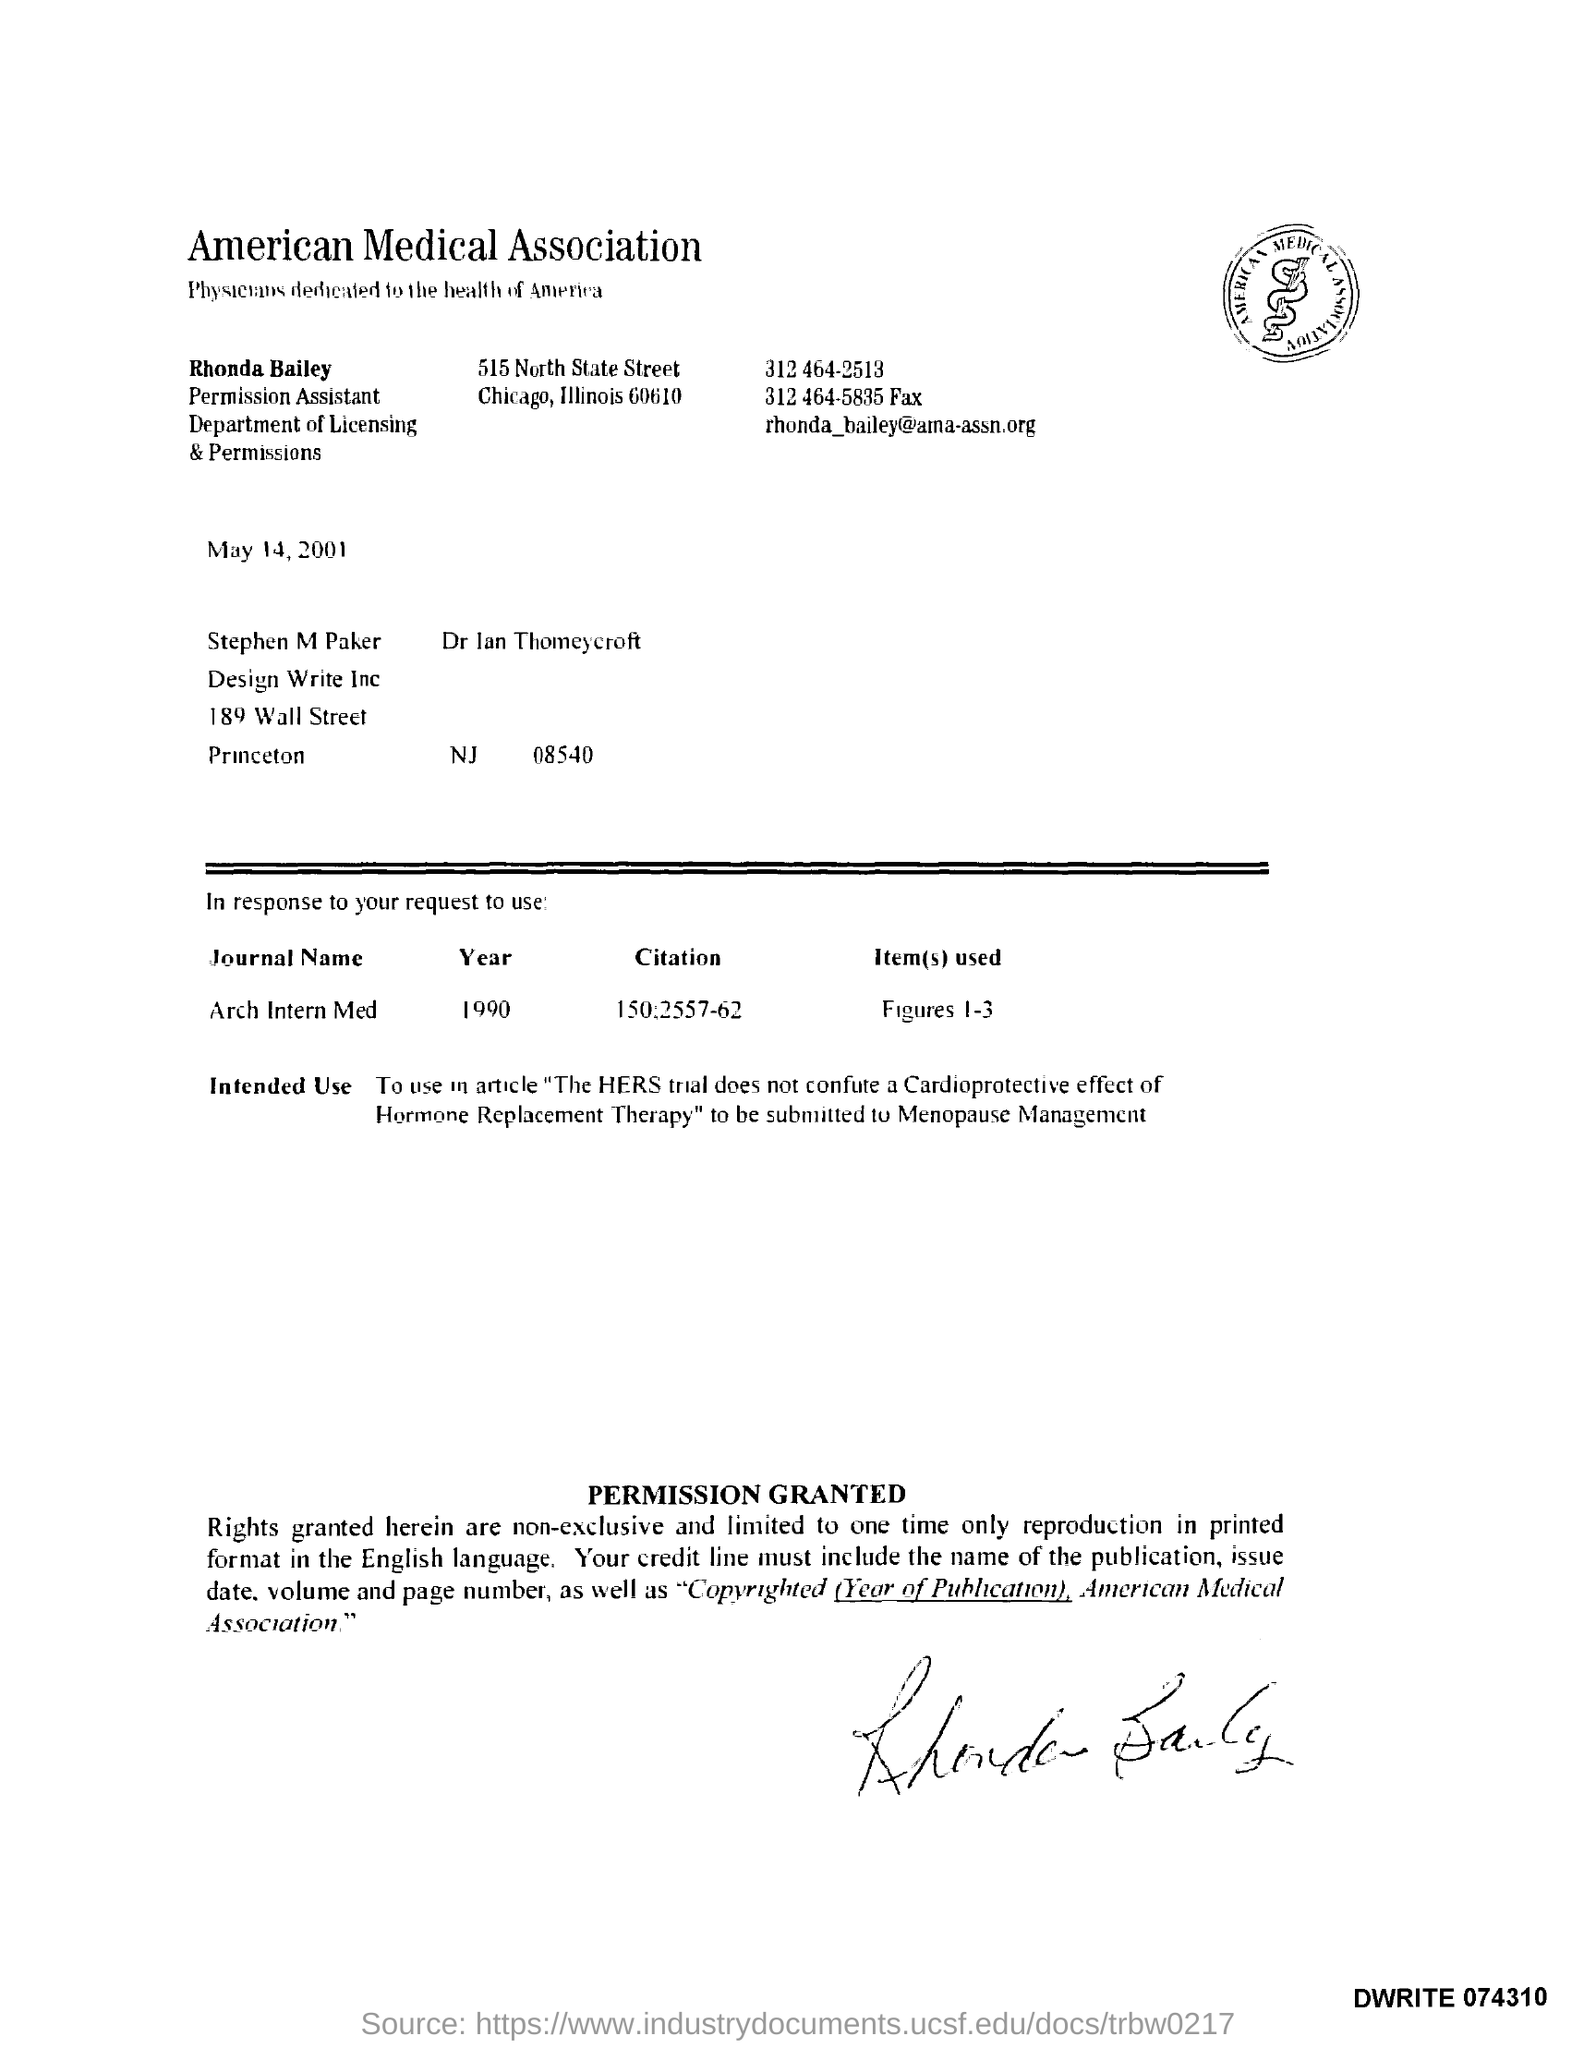Identify some key points in this picture. The fax number is 312 464-5835. The Permission Assistant is Rhonda Bailey. The journal name is 'Arch Intern Med.' 